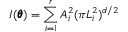Convert formula to latex. <formula><loc_0><loc_0><loc_500><loc_500>I ( \pm b \theta ) = \sum _ { i = 1 } ^ { r } A _ { i } ^ { 2 } ( \pi L _ { i } ^ { 2 } ) ^ { d / 2 }</formula> 